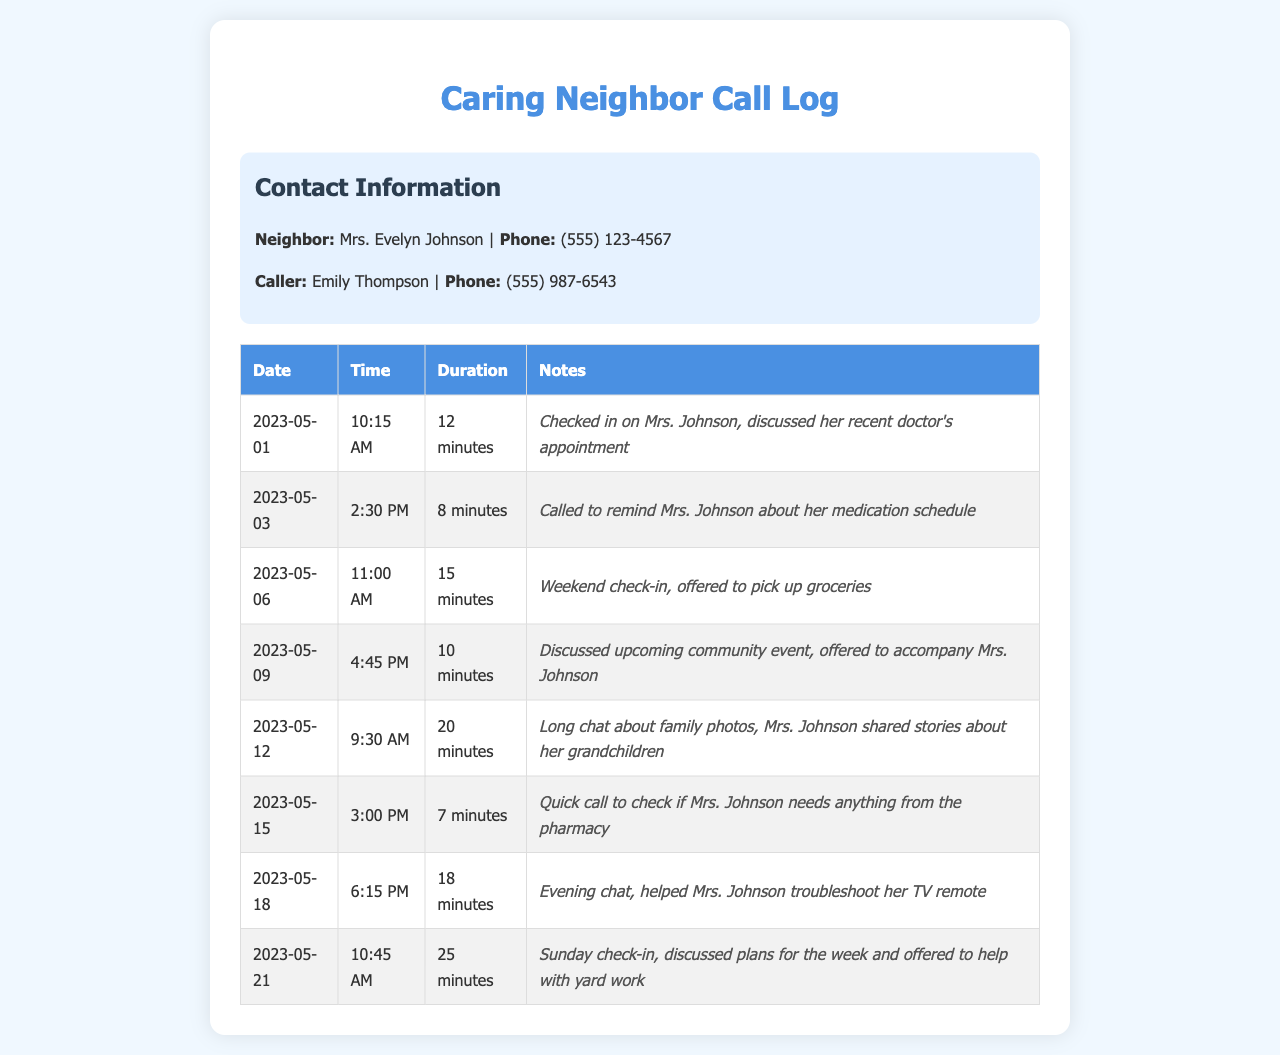what is the name of the neighbor? The name of the neighbor is stated in the contact information section of the document, which is Mrs. Evelyn Johnson.
Answer: Mrs. Evelyn Johnson what is the phone number of the caller? The phone number of the caller, Emily Thompson, is provided in the contact information section as (555) 987-6543.
Answer: (555) 987-6543 how long was the longest call? To find the longest call duration, we review the duration column and identify that the longest call lasted 25 minutes.
Answer: 25 minutes on what date was the check-in about family photos? The date for the call concerning family photos is available in the table, specifically on 2023-05-12.
Answer: 2023-05-12 how many calls were made in the afternoon? The calls made in the afternoon are counted through their recorded times, identifying three calls in total.
Answer: 3 what was discussed during the call on May 6? The notes for the May 6 call indicate the discussion about offering to pick up groceries for Mrs. Johnson.
Answer: Offered to pick up groceries was there a call regarding medication? The notes indicate that there was a call specifically to remind Mrs. Johnson about her medication schedule, which confirms this.
Answer: Yes what time was the evening chat on May 18? The specific time for the evening chat on May 18 can be found in the call log, which states it occurred at 6:15 PM.
Answer: 6:15 PM how many minutes was the shortest call? The shortest call duration is listed as 7 minutes in the table.
Answer: 7 minutes 